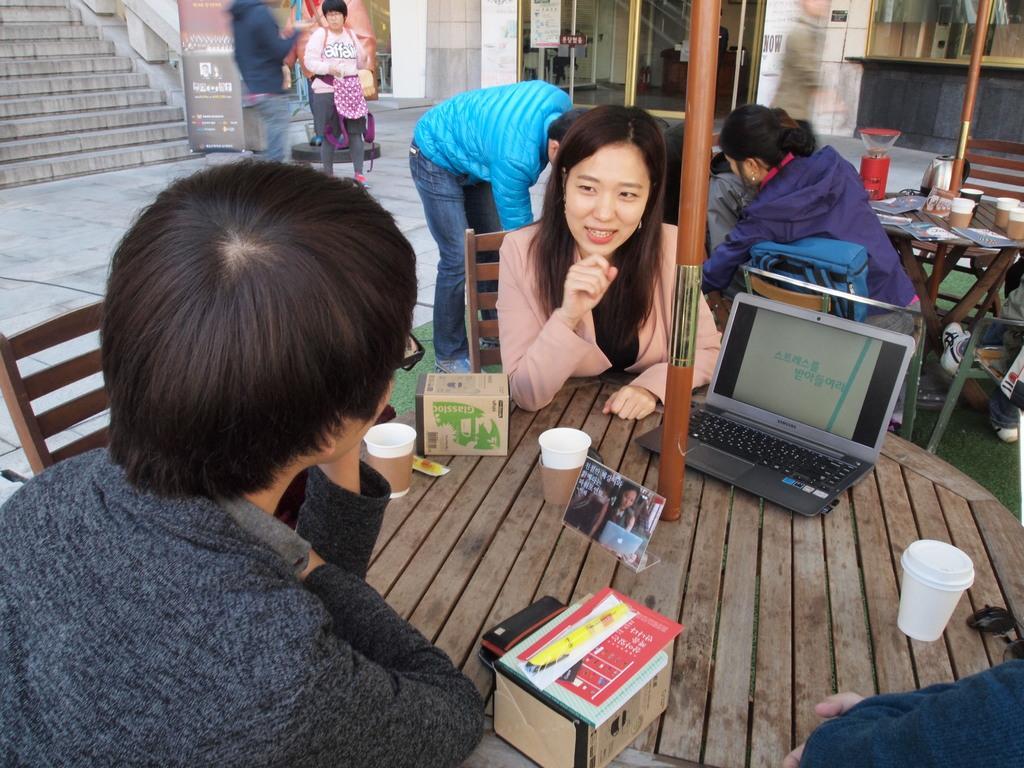In one or two sentences, can you explain what this image depicts? In this picture two of them are sitting on the table with food items and laptop on to of it. In the background we also observed many people sitting on the table. 